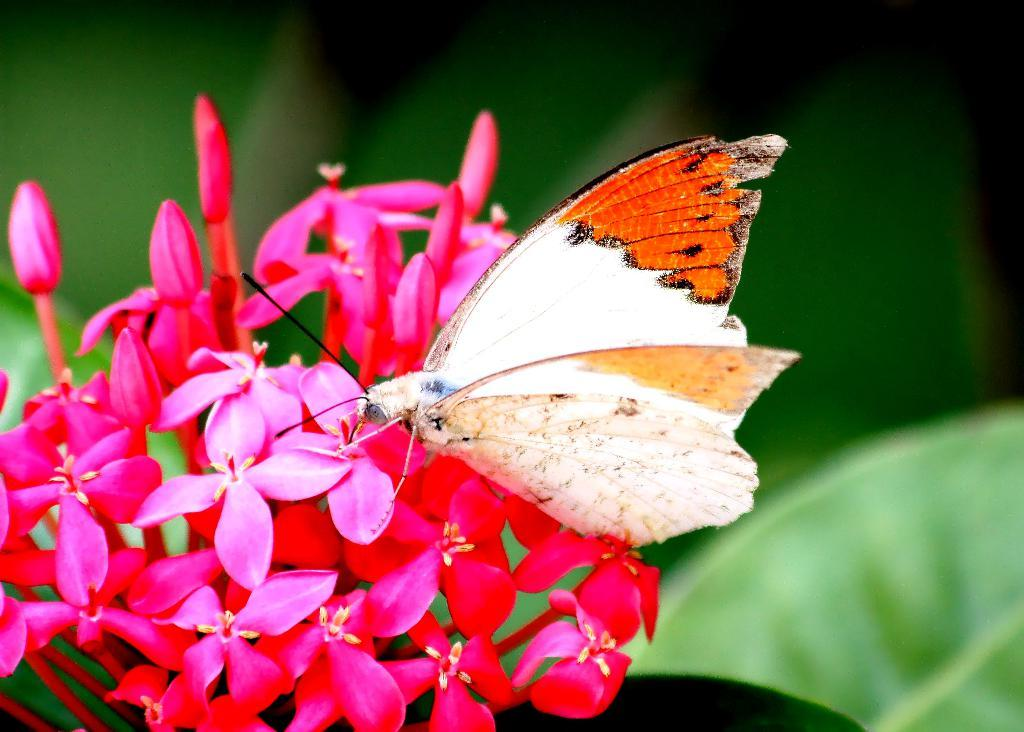What type of plants can be seen in the image? There are flowers in the image. Are there any unopened flowers in the image? Yes, there are buds in the image. What insect is present on the flowers in the image? There is a butterfly on the flowers in the image. What can be seen in the bottom right corner of the image? There is a leaf in the bottom right corner of the image. How would you describe the background of the image? The background of the image is blurry. What time of day is it in the image? The time of day cannot be determined from the image, as there are no clues or indicators present. 